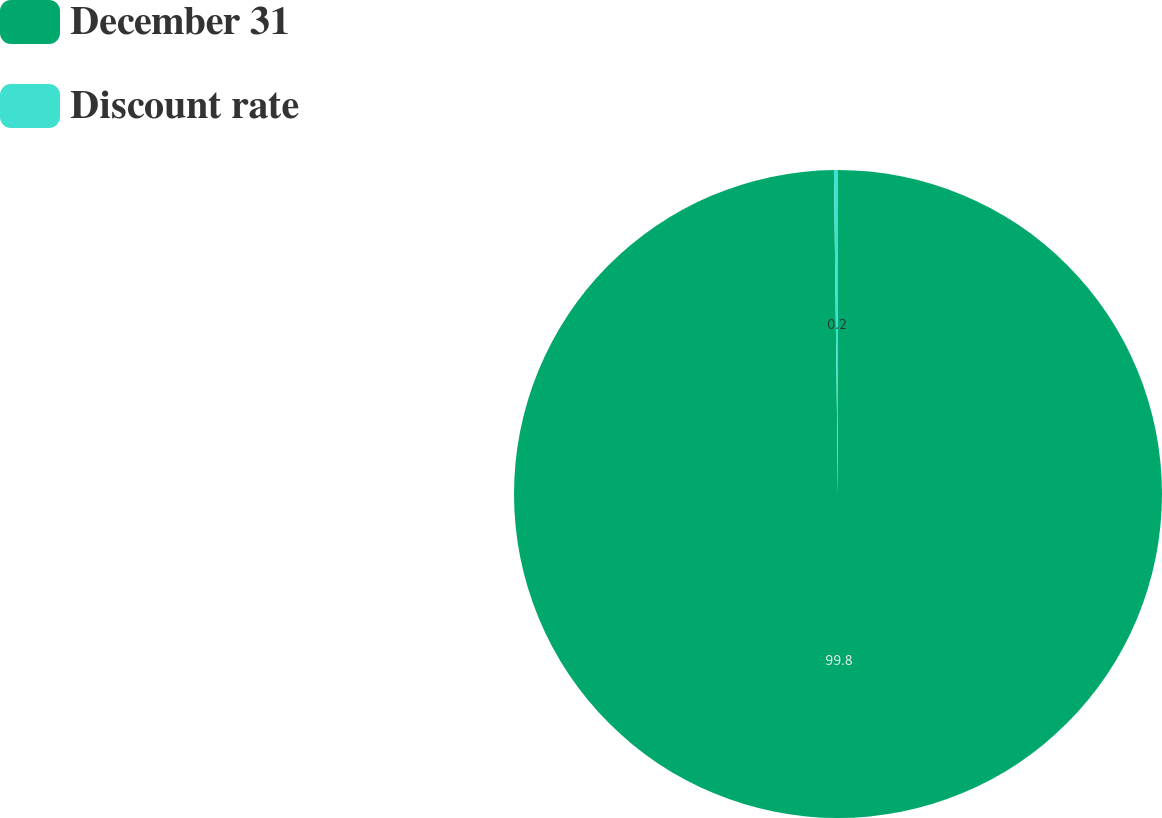<chart> <loc_0><loc_0><loc_500><loc_500><pie_chart><fcel>December 31<fcel>Discount rate<nl><fcel>99.8%<fcel>0.2%<nl></chart> 